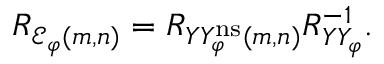<formula> <loc_0><loc_0><loc_500><loc_500>\begin{array} { r } { R _ { { \mathcal { E } } _ { \varphi } ( m , n ) } = R _ { Y Y _ { \varphi } ^ { n s } ( m , n ) } R _ { Y Y _ { \varphi } } ^ { - 1 } . } \end{array}</formula> 